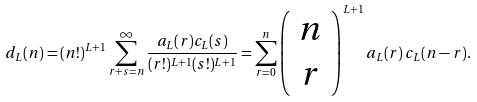Convert formula to latex. <formula><loc_0><loc_0><loc_500><loc_500>d _ { L } ( n ) = ( n ! ) ^ { L + 1 } \sum _ { r + s = n } ^ { \infty } \frac { a _ { L } ( r ) c _ { L } ( s ) } { ( r ! ) ^ { L + 1 } ( s ! ) ^ { L + 1 } } = \sum _ { r = 0 } ^ { n } \left ( \begin{array} { c } n \\ r \end{array} \right ) ^ { L + 1 } a _ { L } ( r ) \, c _ { L } ( n - r ) .</formula> 